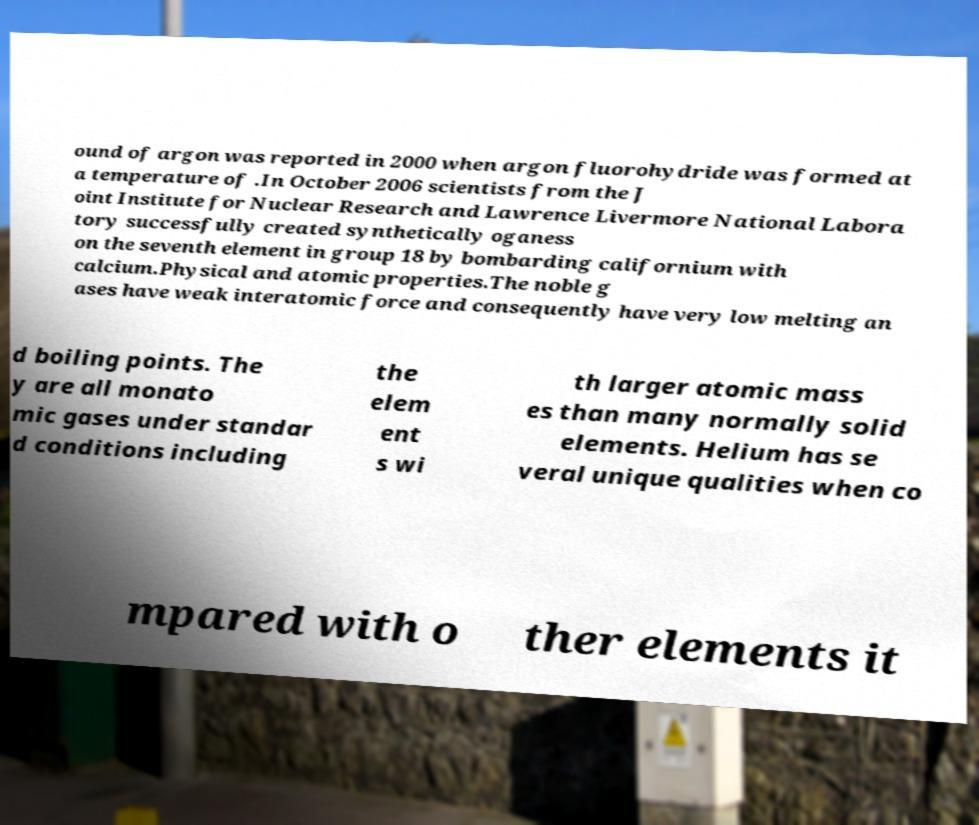Can you read and provide the text displayed in the image?This photo seems to have some interesting text. Can you extract and type it out for me? ound of argon was reported in 2000 when argon fluorohydride was formed at a temperature of .In October 2006 scientists from the J oint Institute for Nuclear Research and Lawrence Livermore National Labora tory successfully created synthetically oganess on the seventh element in group 18 by bombarding californium with calcium.Physical and atomic properties.The noble g ases have weak interatomic force and consequently have very low melting an d boiling points. The y are all monato mic gases under standar d conditions including the elem ent s wi th larger atomic mass es than many normally solid elements. Helium has se veral unique qualities when co mpared with o ther elements it 